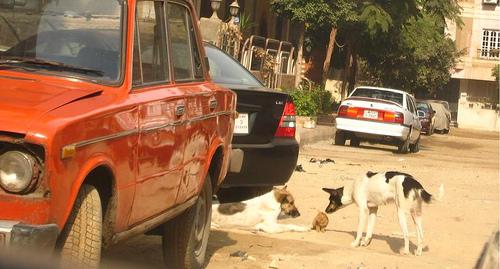What is the dog sniffing?
Write a very short answer. Cat. Is it daytime?
Keep it brief. Yes. How many animals are there?
Keep it brief. 2. 